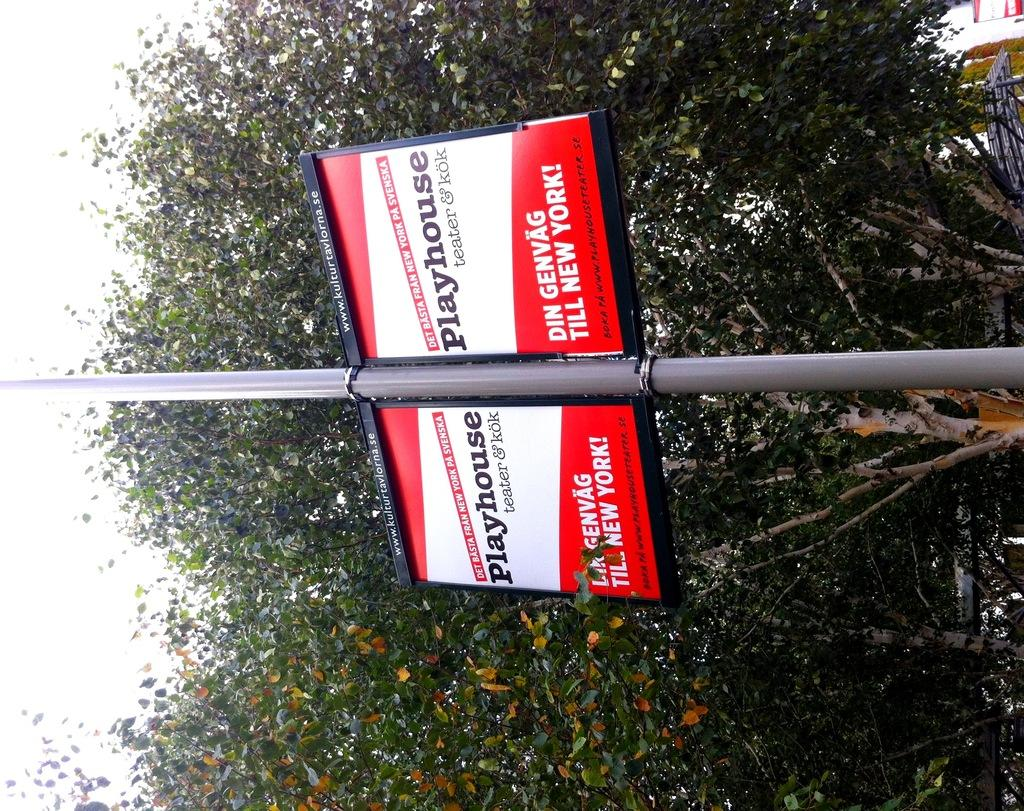How is the image oriented? The image is tilted. What can be seen attached to the pole in the image? There is a board on the pole. What is written or displayed on the board? There is text on the board. What can be seen in the background of the image? There is a tree in the background of the image. What type of battle is depicted in the image? There is no battle depicted in the image; it features a pole with a board and text, as well as a tree in the background. How does the zipper function in the image? There is no zipper present in the image. 